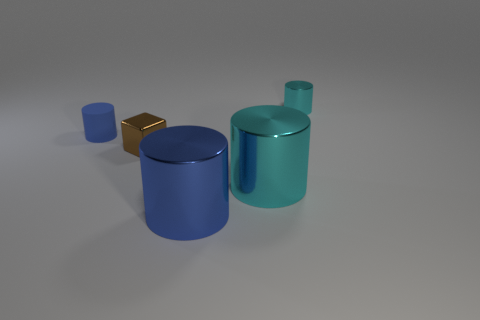The metal object that is the same color as the tiny rubber cylinder is what shape?
Keep it short and to the point. Cylinder. What size is the blue matte object that is the same shape as the small cyan metallic object?
Keep it short and to the point. Small. There is a small blue object behind the tiny cube; is its shape the same as the large blue object?
Your answer should be very brief. Yes. There is a tiny thing in front of the small blue cylinder; what is its color?
Your response must be concise. Brown. How many other objects are the same size as the blue metal object?
Provide a succinct answer. 1. Is there any other thing that has the same shape as the tiny brown thing?
Make the answer very short. No. Are there an equal number of big cyan objects that are behind the tiny brown cube and small red matte things?
Make the answer very short. Yes. What number of blue things are the same material as the brown object?
Offer a very short reply. 1. What is the color of the tiny cylinder that is made of the same material as the brown thing?
Provide a succinct answer. Cyan. Is the blue metal object the same shape as the small brown metal object?
Provide a short and direct response. No. 